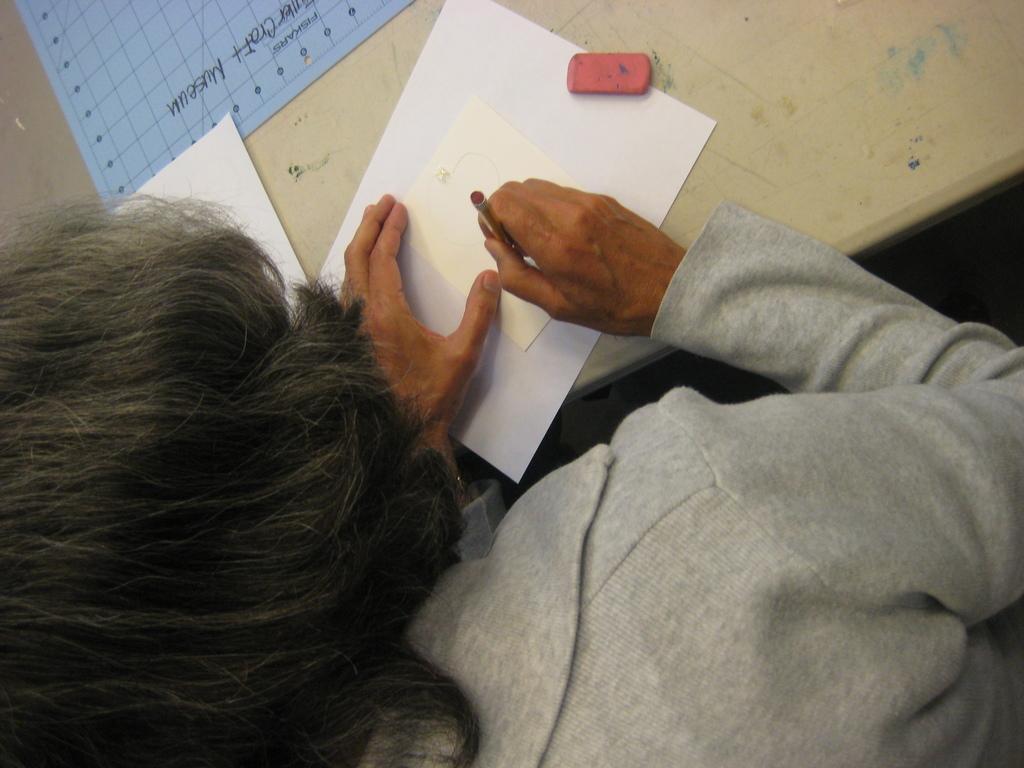Could you give a brief overview of what you see in this image? In this image there is a lady sitting on a chair, in front of there is a table, on that table there are papers. 